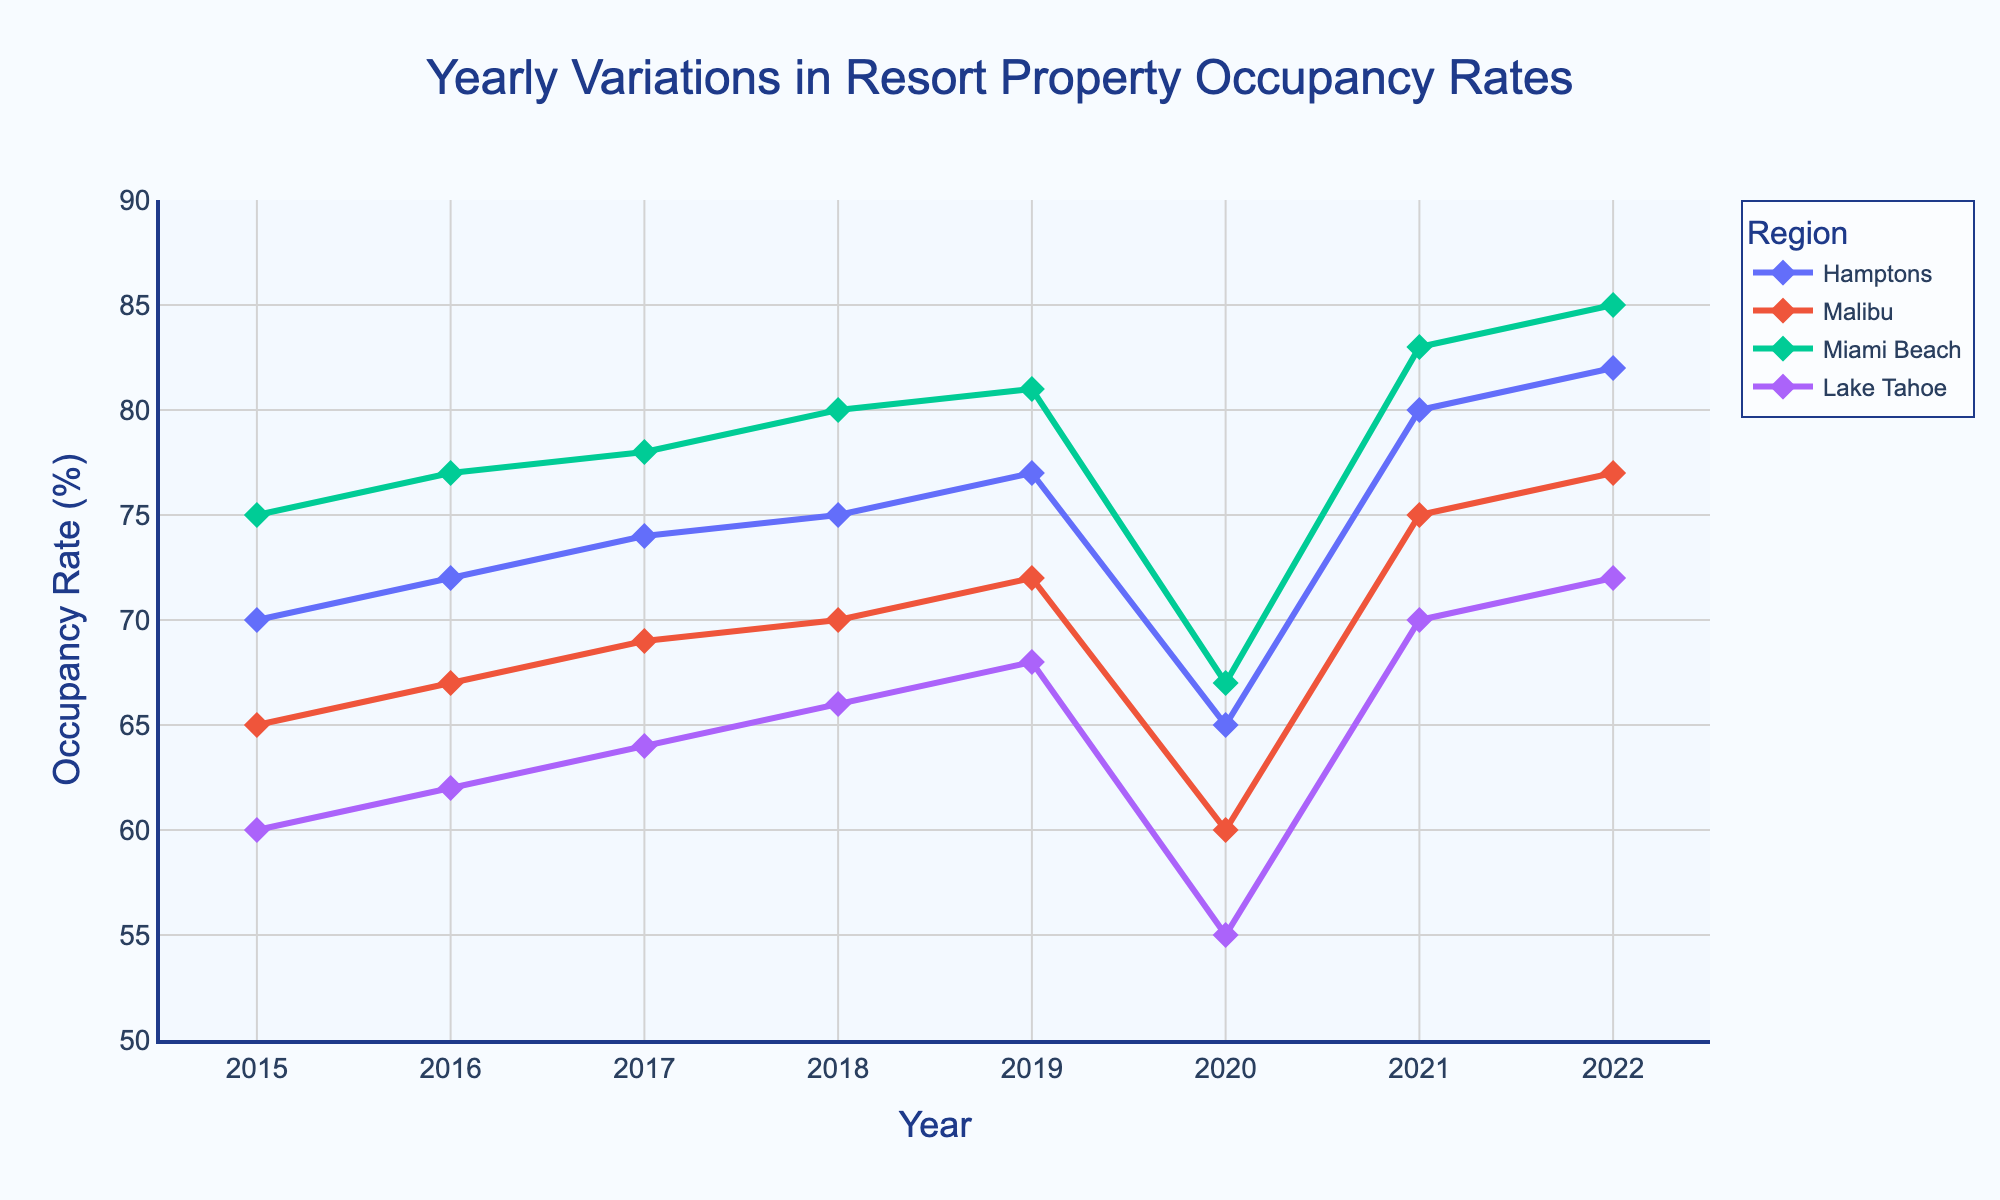What's the title of the plot? The title is located at the top center of the figure and is readable.
Answer: Yearly Variations in Resort Property Occupancy Rates What is the occupancy rate of Malibu in 2020? Look for the 2020 label on the x-axis and trace it up to the Malibu line, then read the corresponding value on the y-axis.
Answer: 60% Which region had the highest occupancy rate in 2022? Check the data points for each region in 2022 and compare the y-axis values, the highest point corresponds to Miami Beach.
Answer: Miami Beach In 2020, which region experienced the lowest occupancy rate? Identify the 2020 data points and compare y-axis values to find the lowest point, which corresponds to Lake Tahoe.
Answer: Lake Tahoe How much did the occupancy rate in the Hamptons change from 2019 to 2020? Locate the Hamptons line and compare the values at the years 2019 and 2020 by calculating the difference. 77% (2019) - 65% (2020) = 12% decrease.
Answer: Decreased by 12% What's the average occupancy rate of Miami Beach from 2015 to 2022? Sum the occupancy rates for Miami Beach over these years and divide by the number of years: (75 + 77 + 78 + 80 + 81 + 67 + 83 + 85) / 8 = 78.25%.
Answer: 78.25% Which year displayed the lowest occupancy rates across all regions? Compare data points for all regions across all years to find the minimum values; 2020 had the lowest rates generally.
Answer: 2020 Did any region have an increasing occupancy rate every year from 2015 to 2019? By examining the trends of each region from 2015 to 2019, observe that all occupancy rates show a consistent upward trend over these years.
Answer: Yes, all regions Which region had the most significant increase in occupancy rate from 2020 to 2021? Compare the difference in occupancy rates for each region between 2020 and 2021 and find the largest increase; Hamptons (80% - 65% = 15%).
Answer: Hamptons Is the occupancy rate of Lake Tahoe higher in 2018 or in 2021? Compare the data points for Lake Tahoe in the years 2018 and 2021: 66% (2018) vs. 70% (2021).
Answer: 2021 